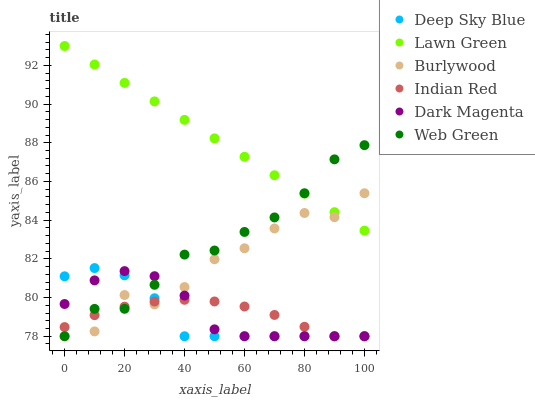Does Deep Sky Blue have the minimum area under the curve?
Answer yes or no. Yes. Does Lawn Green have the maximum area under the curve?
Answer yes or no. Yes. Does Burlywood have the minimum area under the curve?
Answer yes or no. No. Does Burlywood have the maximum area under the curve?
Answer yes or no. No. Is Lawn Green the smoothest?
Answer yes or no. Yes. Is Burlywood the roughest?
Answer yes or no. Yes. Is Deep Sky Blue the smoothest?
Answer yes or no. No. Is Deep Sky Blue the roughest?
Answer yes or no. No. Does Deep Sky Blue have the lowest value?
Answer yes or no. Yes. Does Lawn Green have the highest value?
Answer yes or no. Yes. Does Deep Sky Blue have the highest value?
Answer yes or no. No. Is Indian Red less than Lawn Green?
Answer yes or no. Yes. Is Lawn Green greater than Deep Sky Blue?
Answer yes or no. Yes. Does Dark Magenta intersect Indian Red?
Answer yes or no. Yes. Is Dark Magenta less than Indian Red?
Answer yes or no. No. Is Dark Magenta greater than Indian Red?
Answer yes or no. No. Does Indian Red intersect Lawn Green?
Answer yes or no. No. 